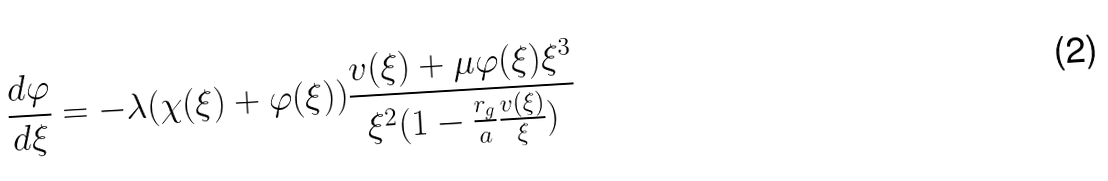Convert formula to latex. <formula><loc_0><loc_0><loc_500><loc_500>\frac { d \varphi } { d \xi } = - \lambda ( \chi ( \xi ) + \varphi ( \xi ) ) \frac { v ( \xi ) + \mu \varphi ( \xi ) \xi ^ { 3 } } { \xi ^ { 2 } ( 1 - \frac { r _ { g } } { a } \frac { v ( \xi ) } { \xi } ) }</formula> 